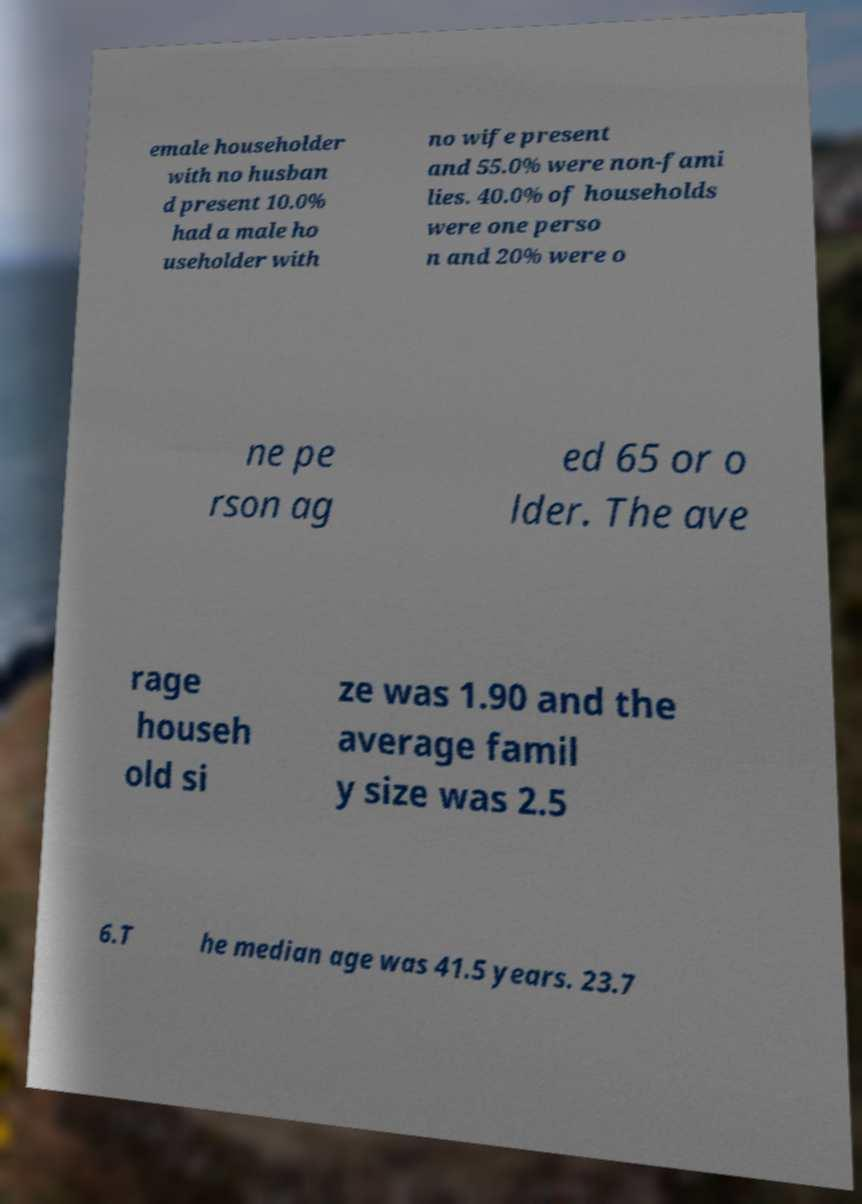For documentation purposes, I need the text within this image transcribed. Could you provide that? emale householder with no husban d present 10.0% had a male ho useholder with no wife present and 55.0% were non-fami lies. 40.0% of households were one perso n and 20% were o ne pe rson ag ed 65 or o lder. The ave rage househ old si ze was 1.90 and the average famil y size was 2.5 6.T he median age was 41.5 years. 23.7 